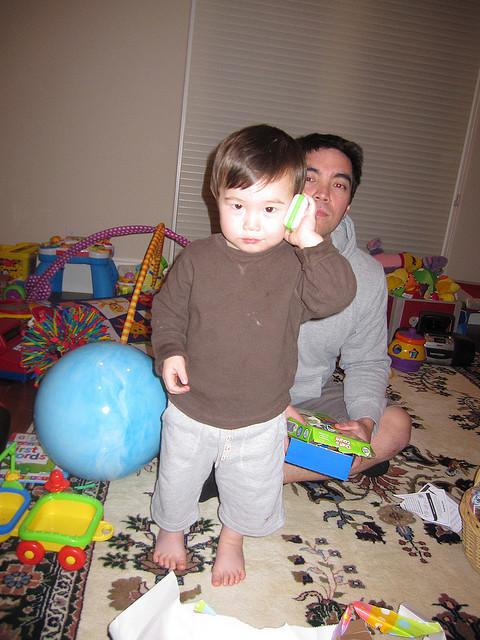How many people are there?
Keep it brief. 2. Whose room are they in?
Keep it brief. Playroom. Is there a blue ball in this picture?
Give a very brief answer. Yes. 